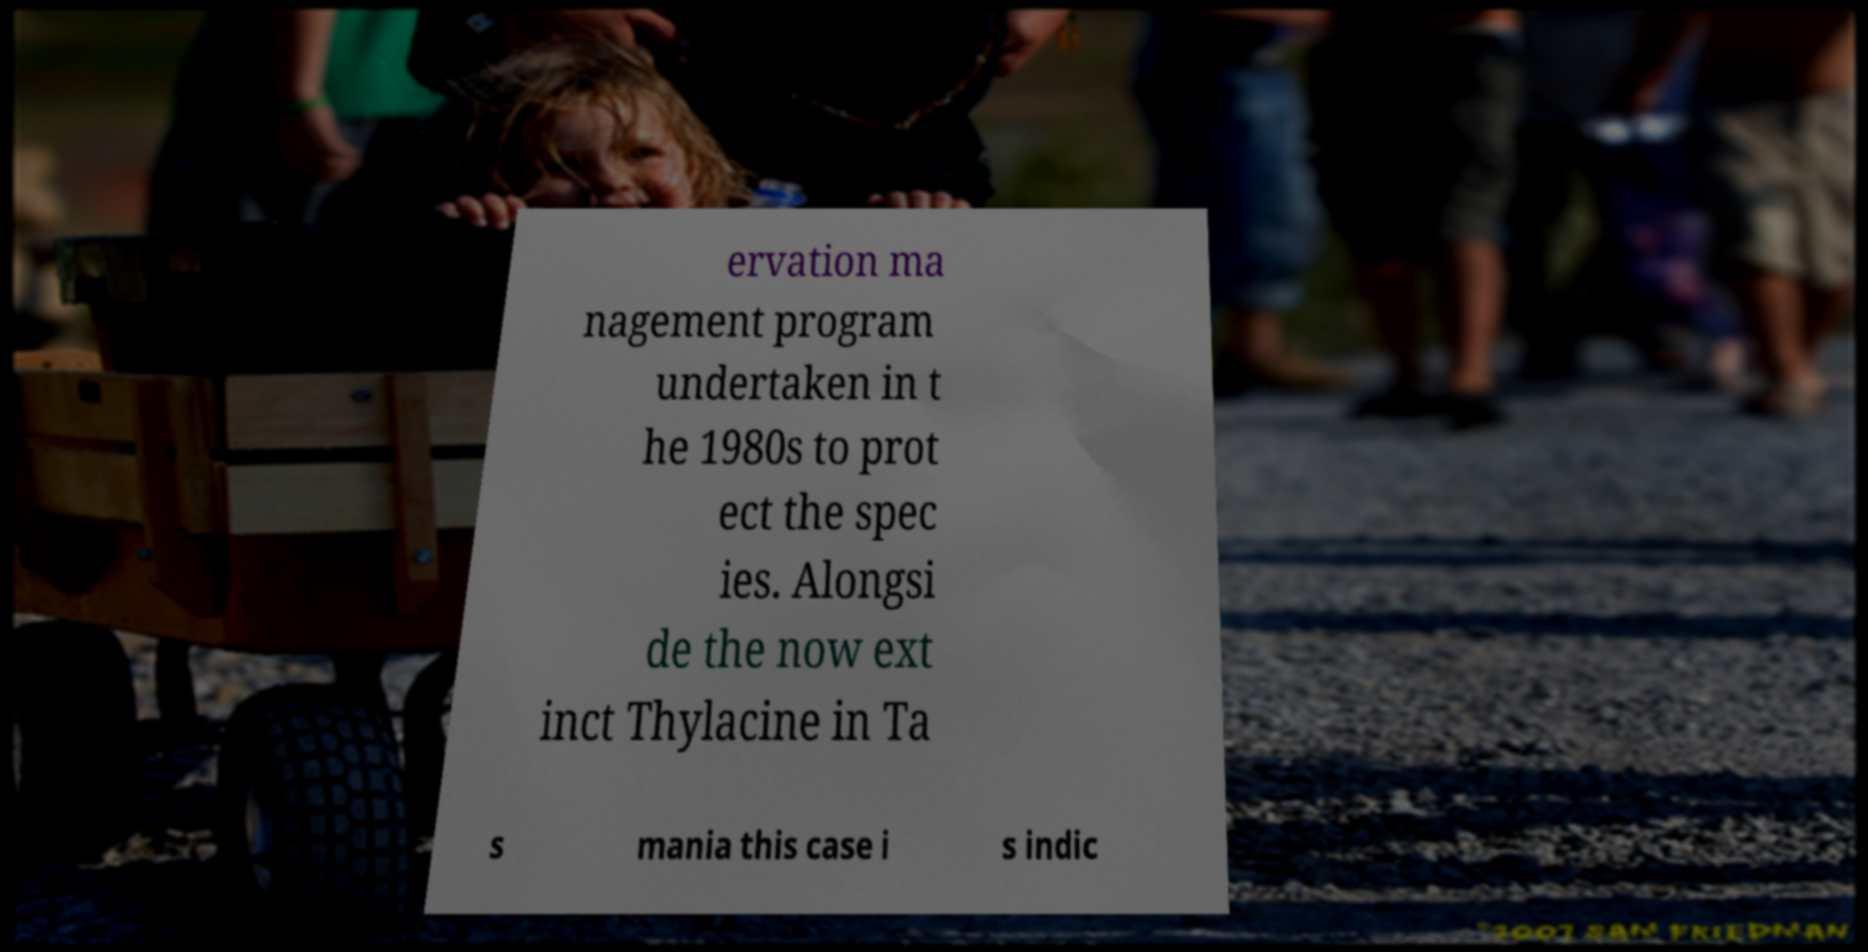Can you read and provide the text displayed in the image?This photo seems to have some interesting text. Can you extract and type it out for me? ervation ma nagement program undertaken in t he 1980s to prot ect the spec ies. Alongsi de the now ext inct Thylacine in Ta s mania this case i s indic 